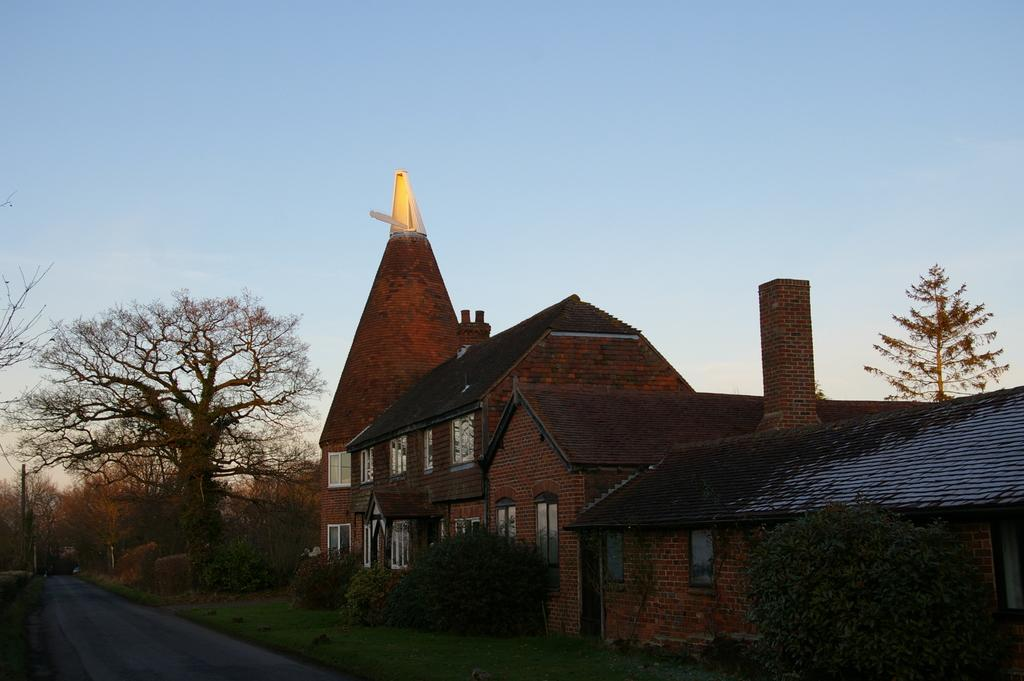What type of structure is in the image? There is a building in the image. What is the landscape in front of the building? Grassy land is present in front of the building. Are there any plants visible in the grassy land? Yes, plants are visible in the grassy land. What can be seen on the left side of the image? Trees are on the left side of the image. What is located at the bottom left of the image? A road is present at the bottom left of the image. What flavor of chess can be seen on the table in the image? There is no chess or table present in the image. How many eggs are visible on the grassy land in the image? There are no eggs visible on the grassy land in the image. 